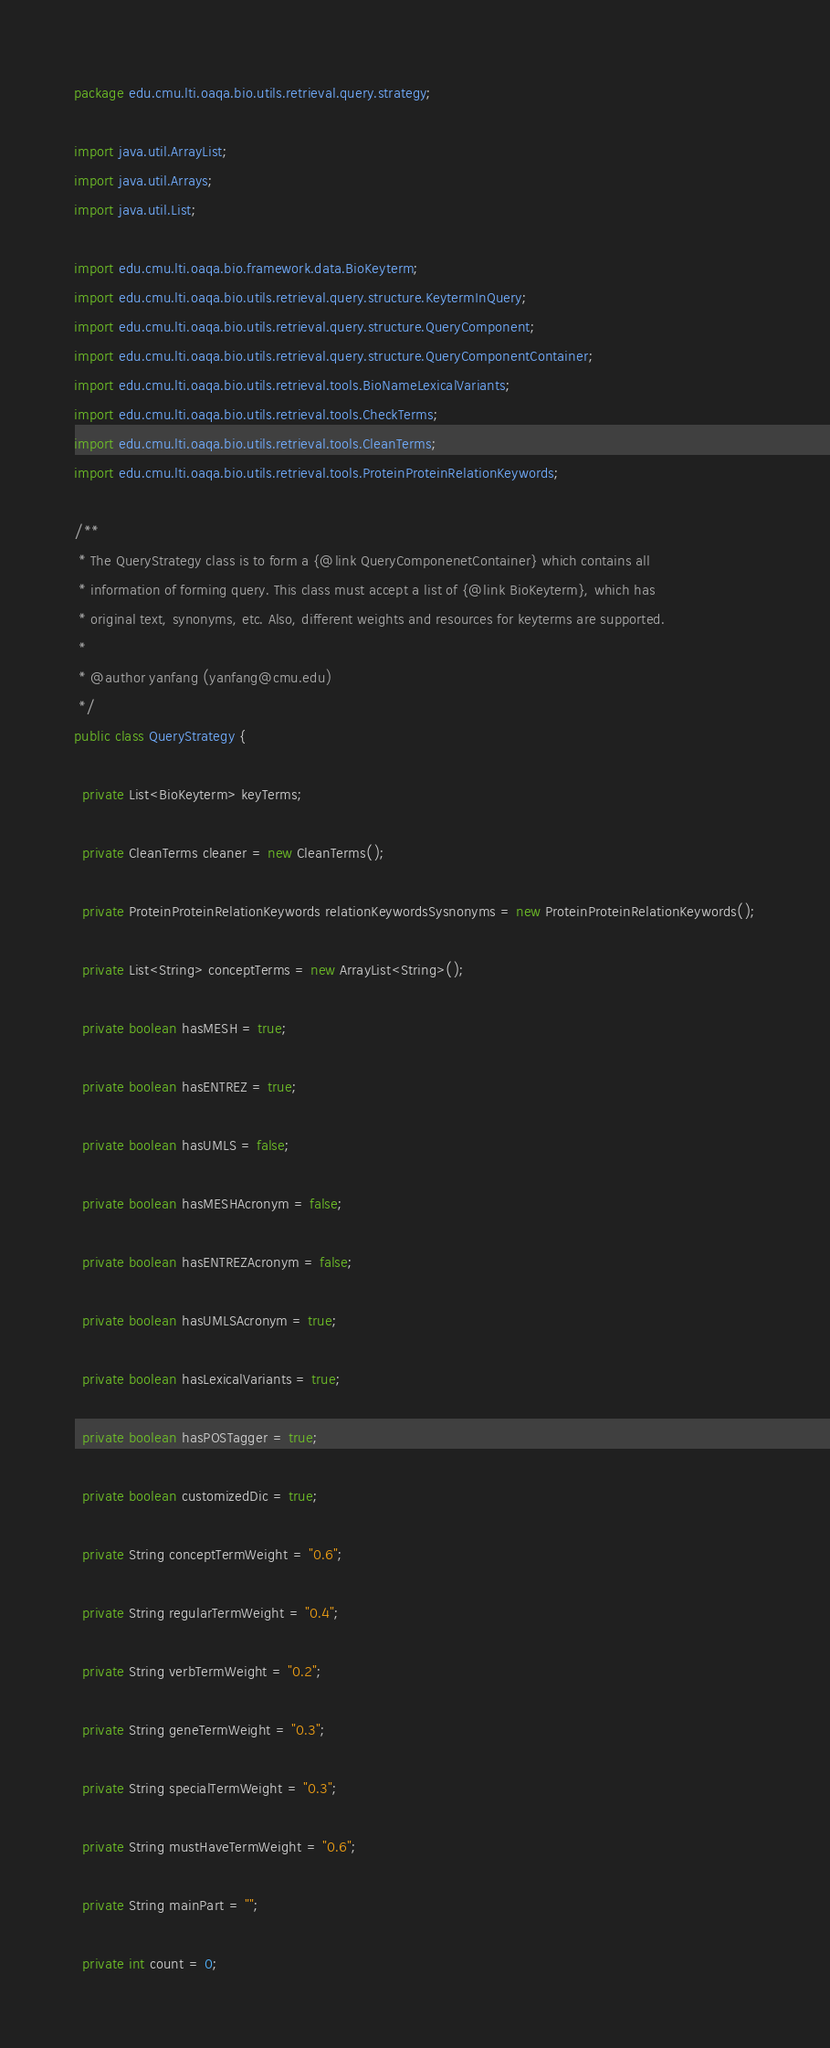<code> <loc_0><loc_0><loc_500><loc_500><_Java_>package edu.cmu.lti.oaqa.bio.utils.retrieval.query.strategy;

import java.util.ArrayList;
import java.util.Arrays;
import java.util.List;

import edu.cmu.lti.oaqa.bio.framework.data.BioKeyterm;
import edu.cmu.lti.oaqa.bio.utils.retrieval.query.structure.KeytermInQuery;
import edu.cmu.lti.oaqa.bio.utils.retrieval.query.structure.QueryComponent;
import edu.cmu.lti.oaqa.bio.utils.retrieval.query.structure.QueryComponentContainer;
import edu.cmu.lti.oaqa.bio.utils.retrieval.tools.BioNameLexicalVariants;
import edu.cmu.lti.oaqa.bio.utils.retrieval.tools.CheckTerms;
import edu.cmu.lti.oaqa.bio.utils.retrieval.tools.CleanTerms;
import edu.cmu.lti.oaqa.bio.utils.retrieval.tools.ProteinProteinRelationKeywords;

/**
 * The QueryStrategy class is to form a {@link QueryComponenetContainer} which contains all
 * information of forming query. This class must accept a list of {@link BioKeyterm}, which has
 * original text, synonyms, etc. Also, different weights and resources for keyterms are supported.
 * 
 * @author yanfang (yanfang@cmu.edu)
 */
public class QueryStrategy {

  private List<BioKeyterm> keyTerms;

  private CleanTerms cleaner = new CleanTerms();

  private ProteinProteinRelationKeywords relationKeywordsSysnonyms = new ProteinProteinRelationKeywords();

  private List<String> conceptTerms = new ArrayList<String>();

  private boolean hasMESH = true;

  private boolean hasENTREZ = true;

  private boolean hasUMLS = false;

  private boolean hasMESHAcronym = false;

  private boolean hasENTREZAcronym = false;

  private boolean hasUMLSAcronym = true;

  private boolean hasLexicalVariants = true;

  private boolean hasPOSTagger = true;

  private boolean customizedDic = true;

  private String conceptTermWeight = "0.6";

  private String regularTermWeight = "0.4";

  private String verbTermWeight = "0.2";

  private String geneTermWeight = "0.3";

  private String specialTermWeight = "0.3";

  private String mustHaveTermWeight = "0.6";

  private String mainPart = "";

  private int count = 0;
</code> 